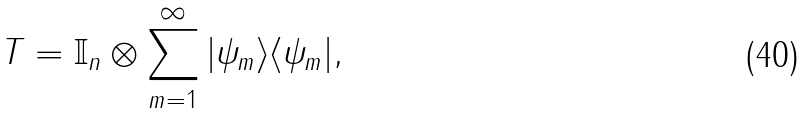<formula> <loc_0><loc_0><loc_500><loc_500>T = \mathbb { I } _ { n } \otimes \sum _ { m = 1 } ^ { \infty } | \psi _ { m } \rangle \langle \psi _ { m } | ,</formula> 